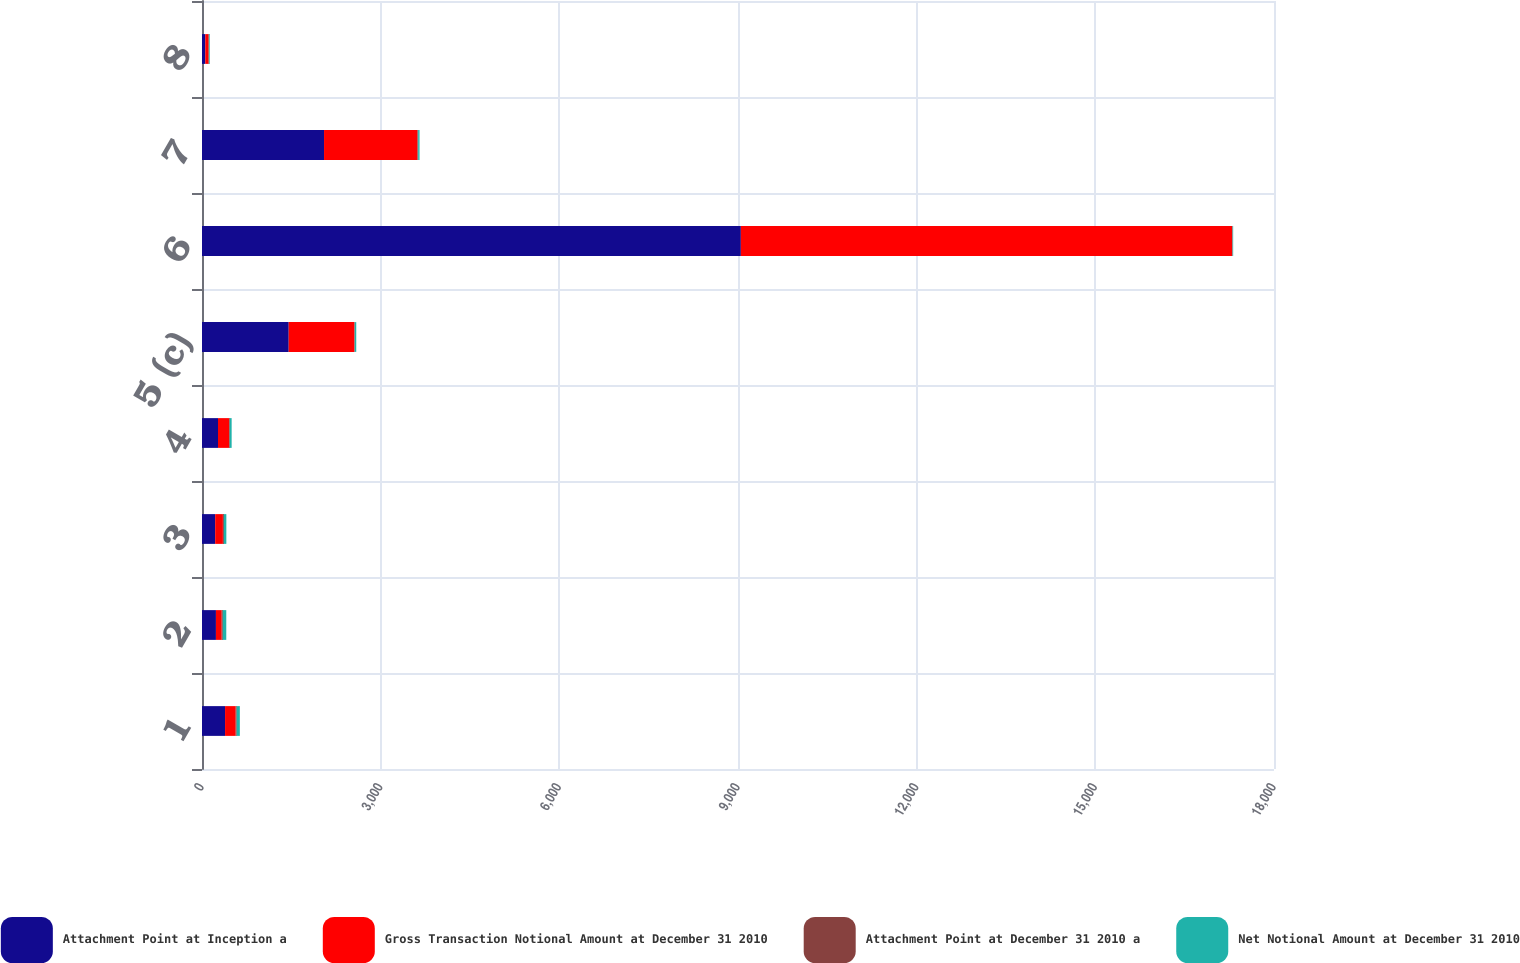<chart> <loc_0><loc_0><loc_500><loc_500><stacked_bar_chart><ecel><fcel>1<fcel>2<fcel>3<fcel>4<fcel>5 (c)<fcel>6<fcel>7<fcel>8<nl><fcel>Attachment Point at Inception a<fcel>387<fcel>234<fcel>221<fcel>269<fcel>1456<fcel>9048<fcel>2049<fcel>55.215<nl><fcel>Gross Transaction Notional Amount at December 31 2010<fcel>179<fcel>97<fcel>130<fcel>184<fcel>1102<fcel>8250<fcel>1568<fcel>55.215<nl><fcel>Attachment Point at December 31 2010 a<fcel>17.01<fcel>18.48<fcel>16.81<fcel>13.19<fcel>7.95<fcel>7.5<fcel>12.4<fcel>9.2<nl><fcel>Net Notional Amount at December 31 2010<fcel>52.35<fcel>58.08<fcel>40.99<fcel>31.62<fcel>24.13<fcel>8.82<fcel>23.48<fcel>11.37<nl></chart> 